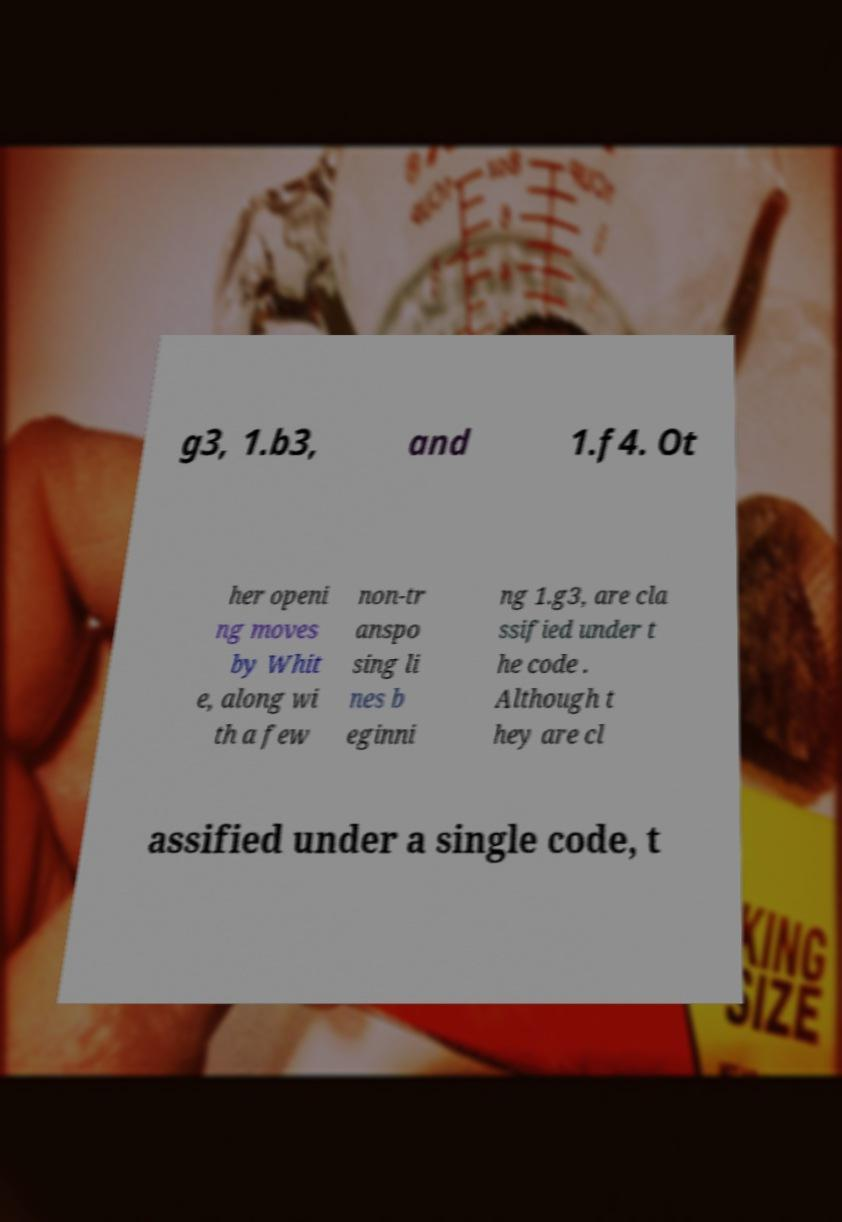Can you accurately transcribe the text from the provided image for me? g3, 1.b3, and 1.f4. Ot her openi ng moves by Whit e, along wi th a few non-tr anspo sing li nes b eginni ng 1.g3, are cla ssified under t he code . Although t hey are cl assified under a single code, t 